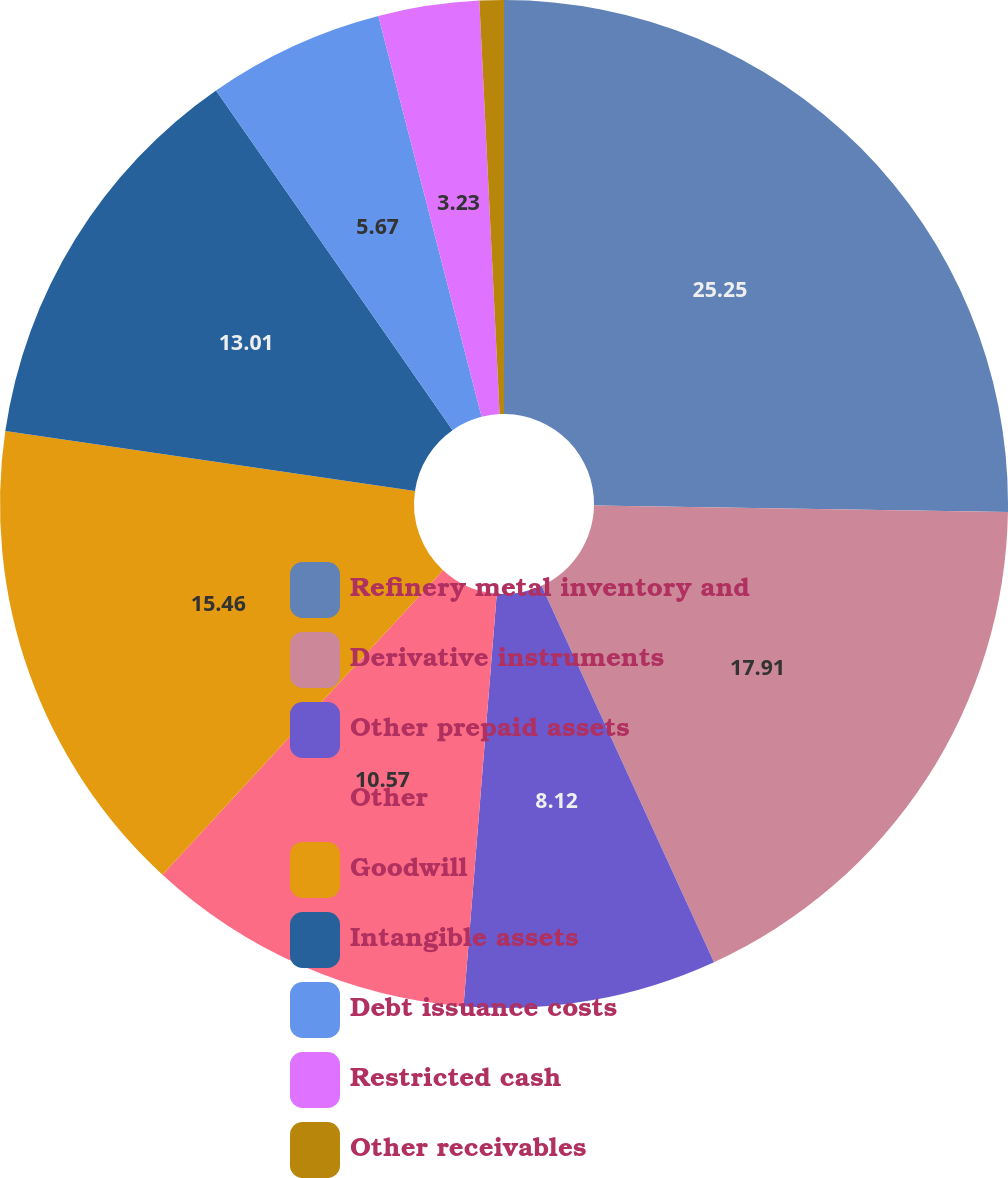<chart> <loc_0><loc_0><loc_500><loc_500><pie_chart><fcel>Refinery metal inventory and<fcel>Derivative instruments<fcel>Other prepaid assets<fcel>Other<fcel>Goodwill<fcel>Intangible assets<fcel>Debt issuance costs<fcel>Restricted cash<fcel>Other receivables<nl><fcel>25.25%<fcel>17.91%<fcel>8.12%<fcel>10.57%<fcel>15.46%<fcel>13.01%<fcel>5.67%<fcel>3.23%<fcel>0.78%<nl></chart> 